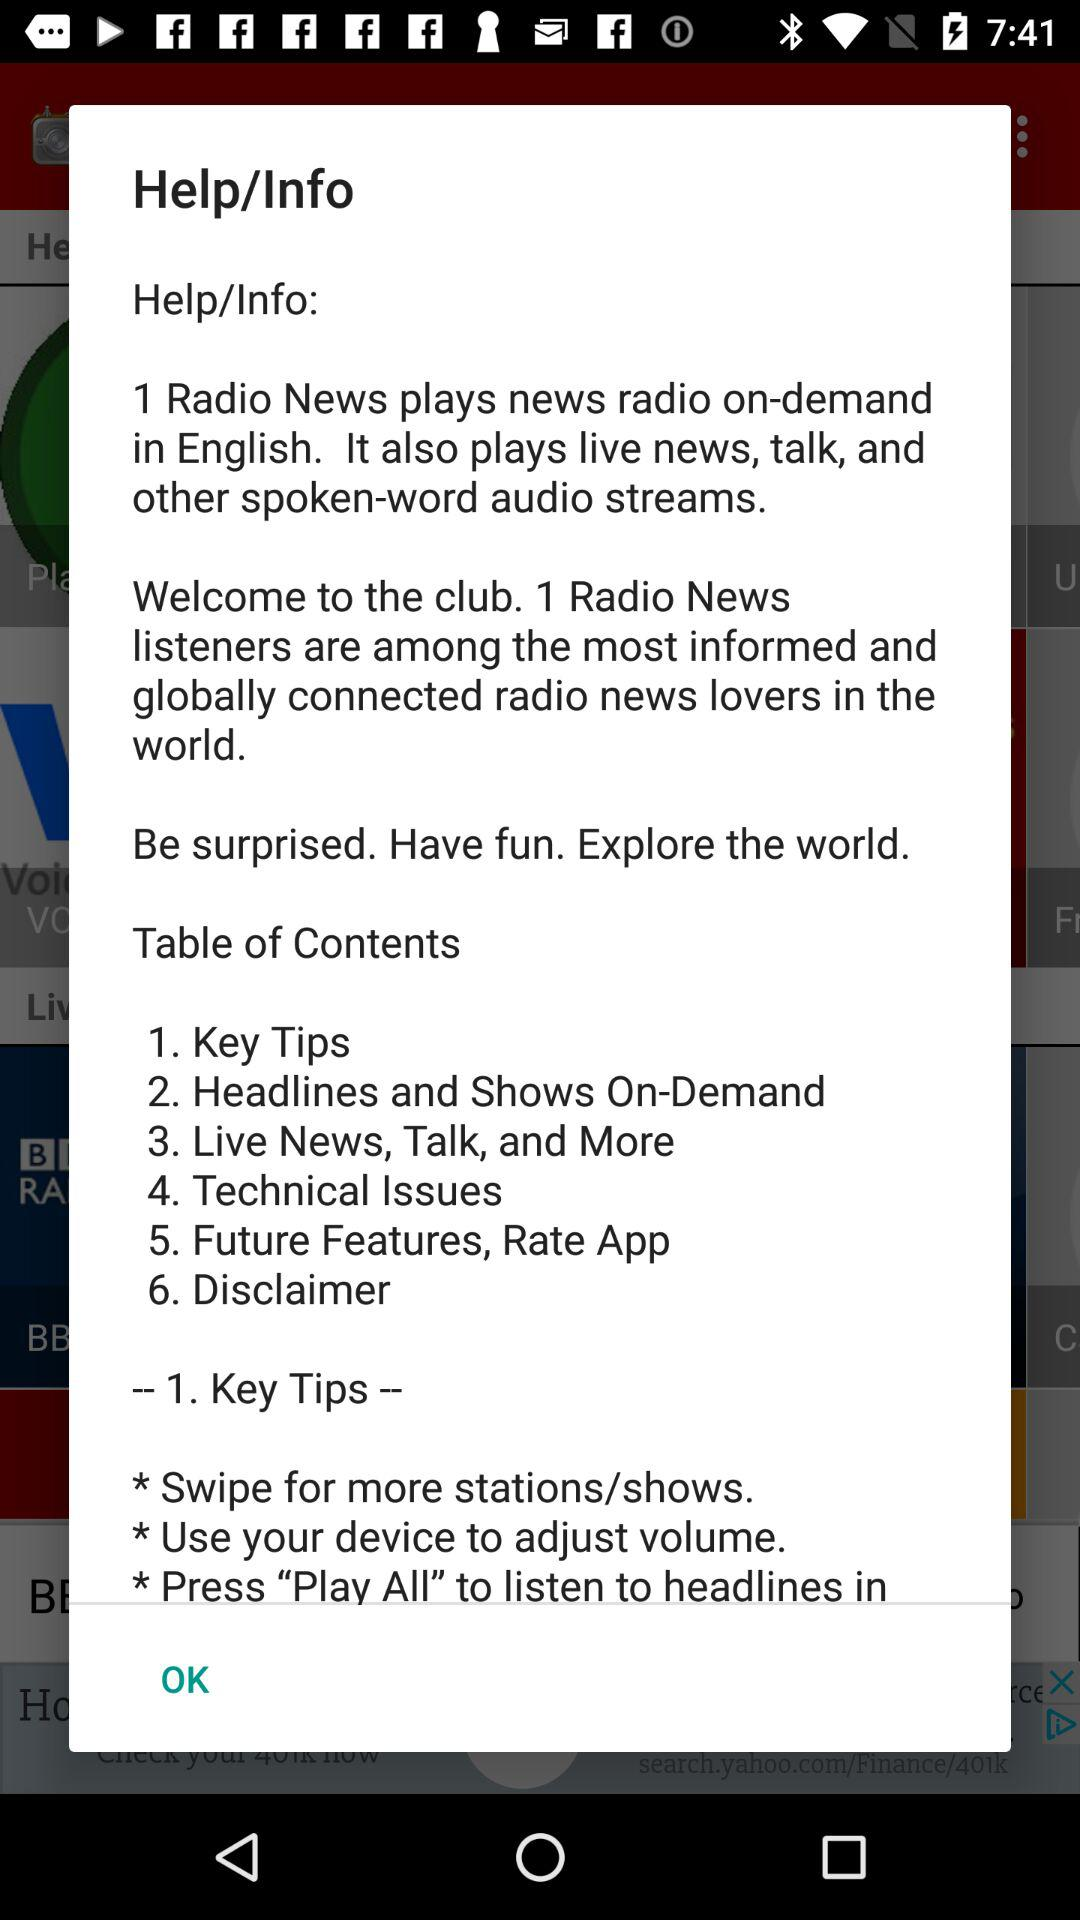How many items are in the table of contents?
Answer the question using a single word or phrase. 6 